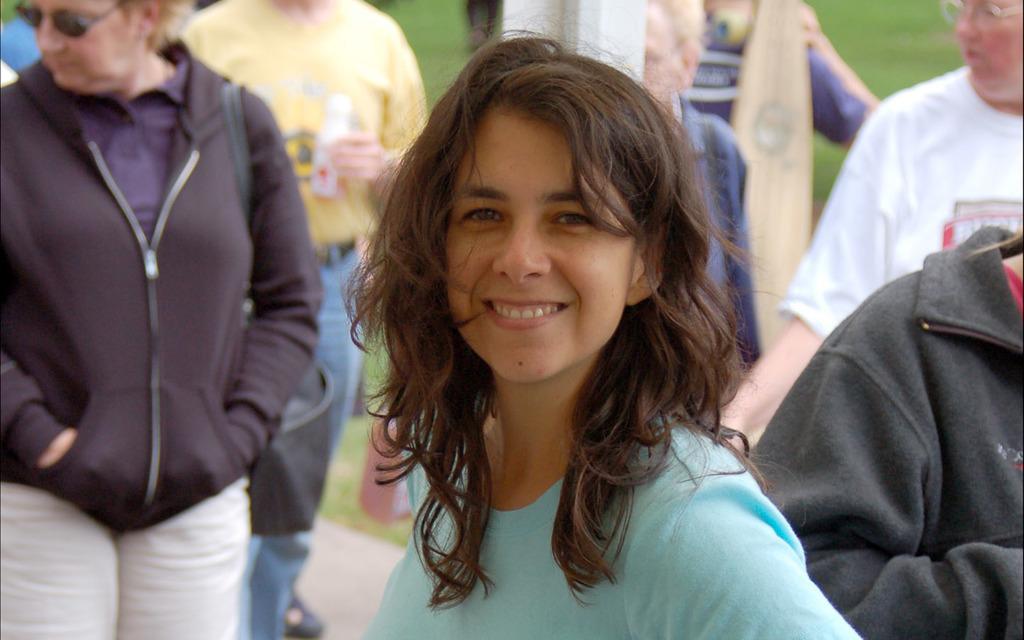How would you summarize this image in a sentence or two? This image is taken outdoors. In the background there is a ground with grass on it and a few people are walking on the road. In the middle of the image there is a girl with a smiling face. On the left side of the image there is a man. 